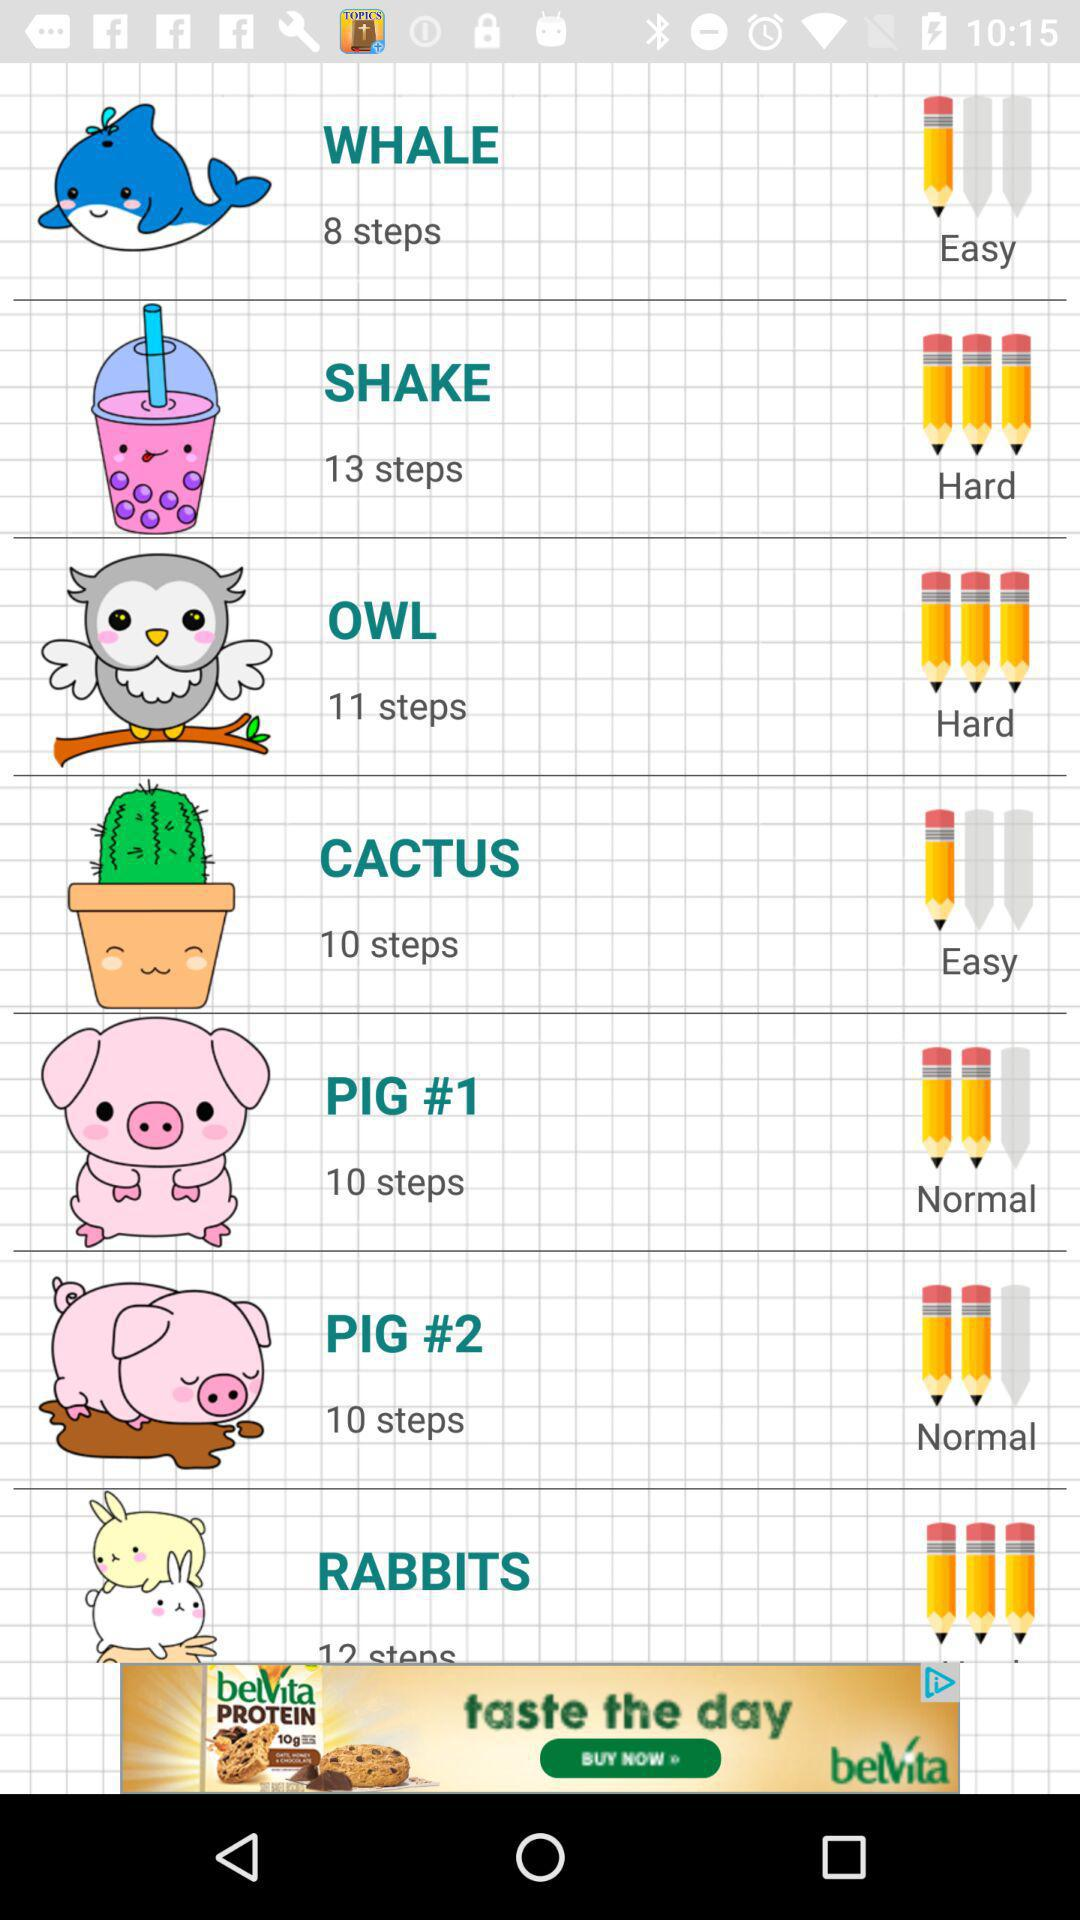Is "WHALE" easy or hard?
Answer the question using a single word or phrase. "WHALE" is Easy. 